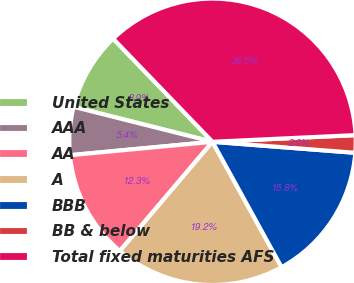Convert chart to OTSL. <chart><loc_0><loc_0><loc_500><loc_500><pie_chart><fcel>United States<fcel>AAA<fcel>AA<fcel>A<fcel>BBB<fcel>BB & below<fcel>Total fixed maturities AFS<nl><fcel>8.87%<fcel>5.42%<fcel>12.31%<fcel>19.21%<fcel>15.76%<fcel>1.97%<fcel>36.46%<nl></chart> 